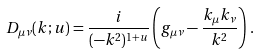Convert formula to latex. <formula><loc_0><loc_0><loc_500><loc_500>D _ { \mu \nu } ( k ; u ) = \frac { i } { ( - k ^ { 2 } ) ^ { 1 + u } } \left ( g _ { \mu \nu } - \frac { k _ { \mu } k _ { \nu } } { k ^ { 2 } } \right ) \, .</formula> 